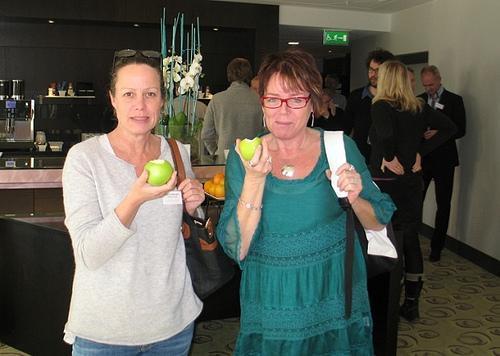How many women are in the picture?
Give a very brief answer. 3. How many apples are pictured?
Give a very brief answer. 2. How many people are wearing glasses?
Give a very brief answer. 1. 